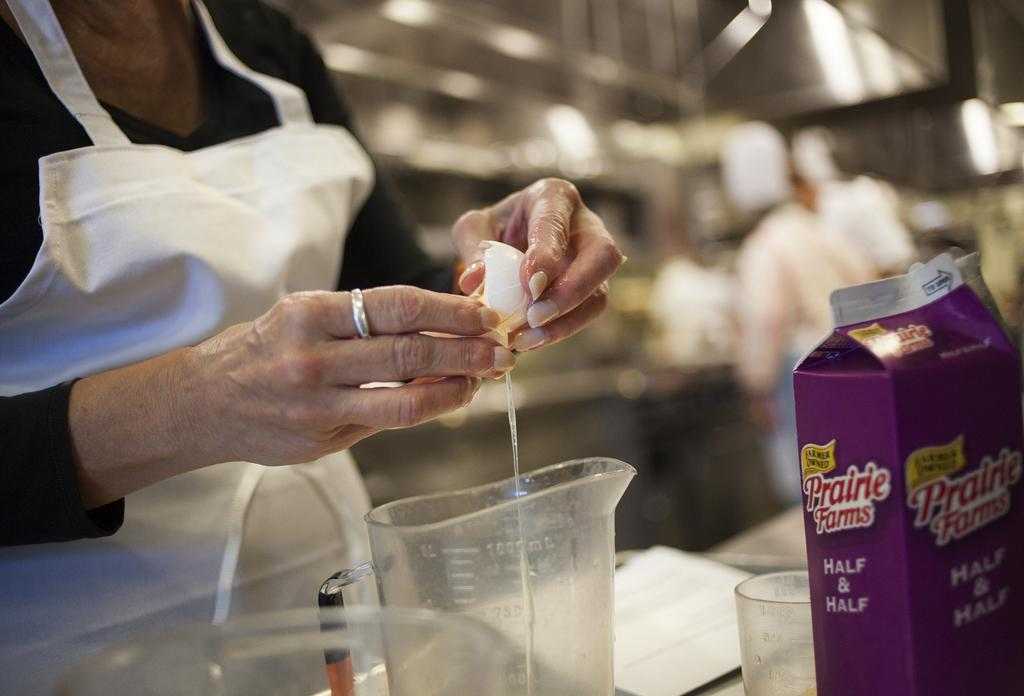<image>
Summarize the visual content of the image. The chef is using Prairie Farms Half & Half. 